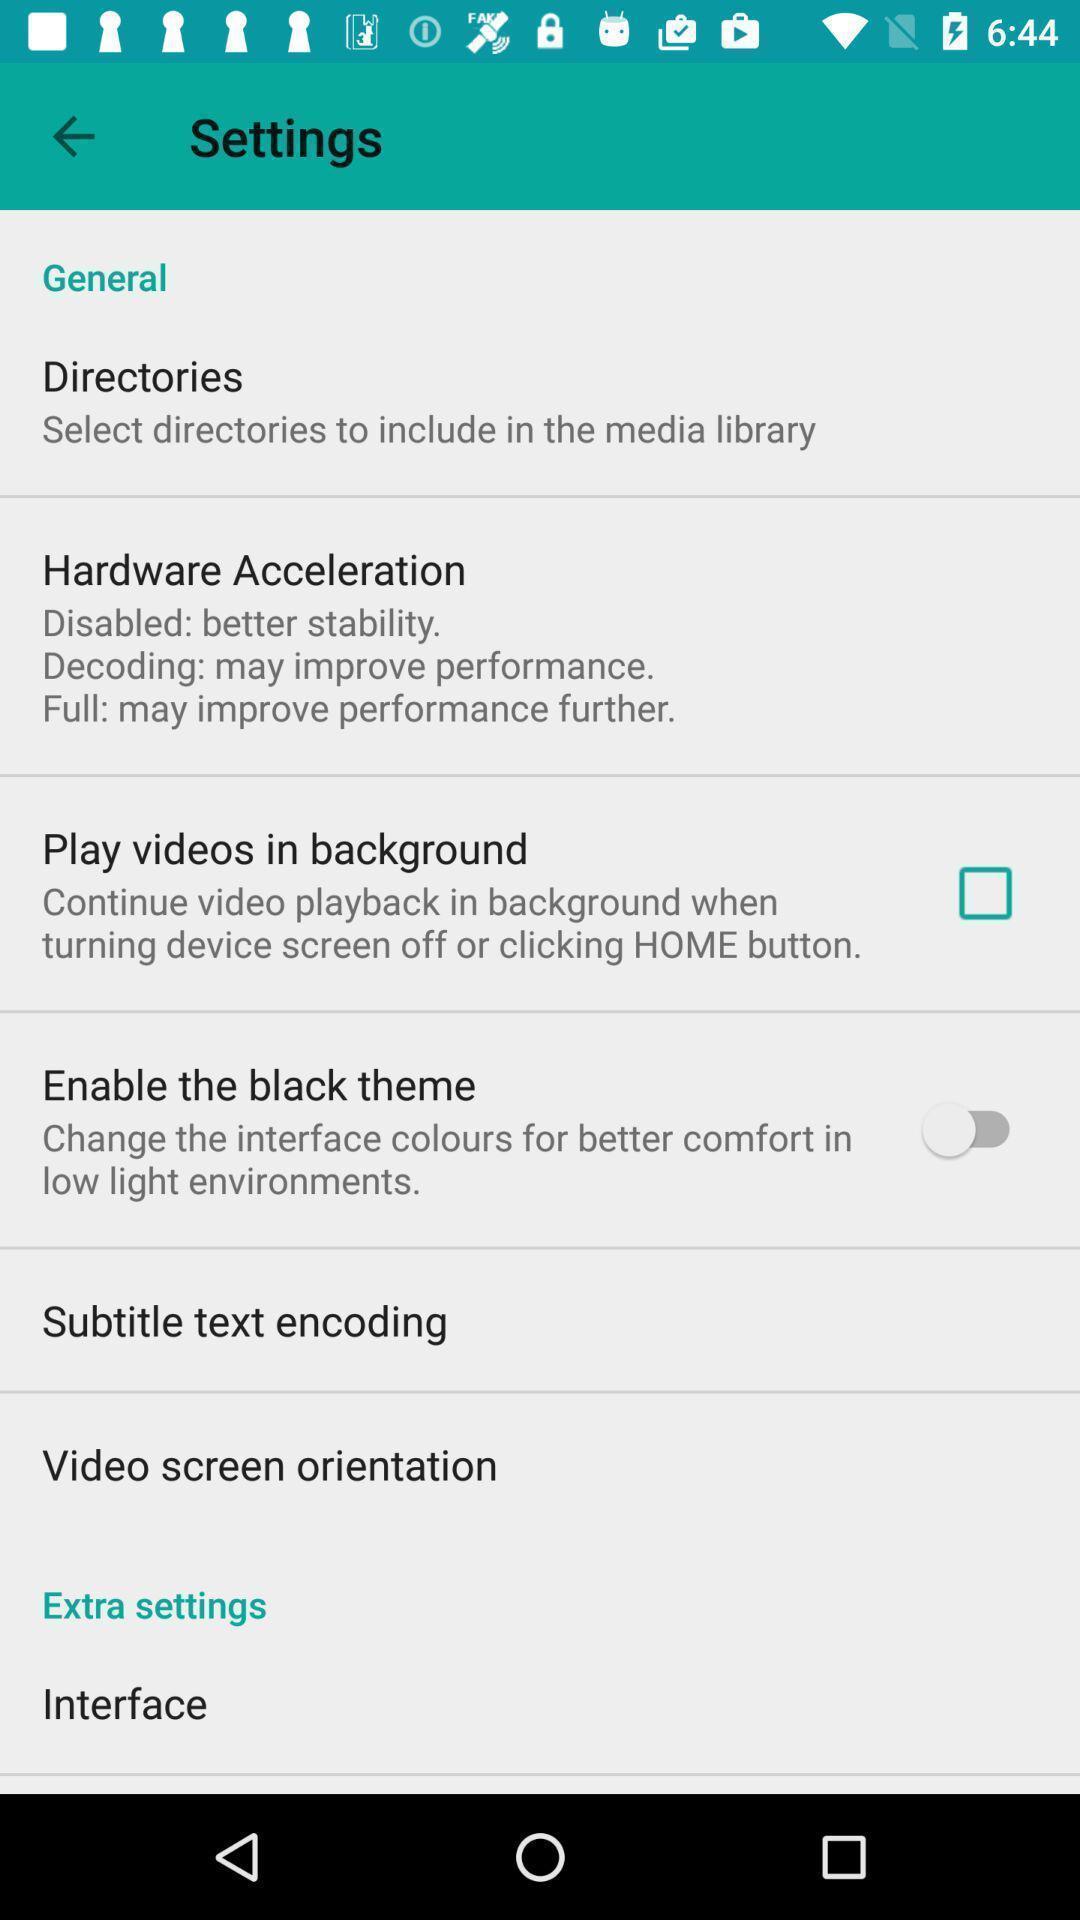Summarize the main components in this picture. Settings page displayed of an video application. 